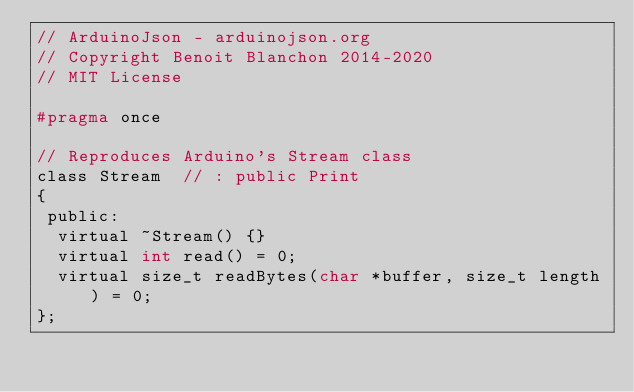<code> <loc_0><loc_0><loc_500><loc_500><_C_>// ArduinoJson - arduinojson.org
// Copyright Benoit Blanchon 2014-2020
// MIT License

#pragma once

// Reproduces Arduino's Stream class
class Stream  // : public Print
{
 public:
  virtual ~Stream() {}
  virtual int read() = 0;
  virtual size_t readBytes(char *buffer, size_t length) = 0;
};
</code> 